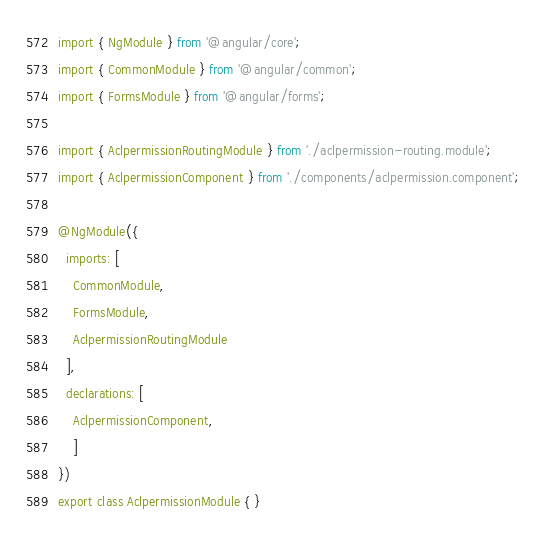Convert code to text. <code><loc_0><loc_0><loc_500><loc_500><_TypeScript_>import { NgModule } from '@angular/core';
import { CommonModule } from '@angular/common';
import { FormsModule } from '@angular/forms';

import { AclpermissionRoutingModule } from './aclpermission-routing.module';
import { AclpermissionComponent } from './components/aclpermission.component';

@NgModule({
  imports: [
    CommonModule,
    FormsModule,
    AclpermissionRoutingModule
  ],
  declarations: [
    AclpermissionComponent,
    ]
})
export class AclpermissionModule { }
</code> 